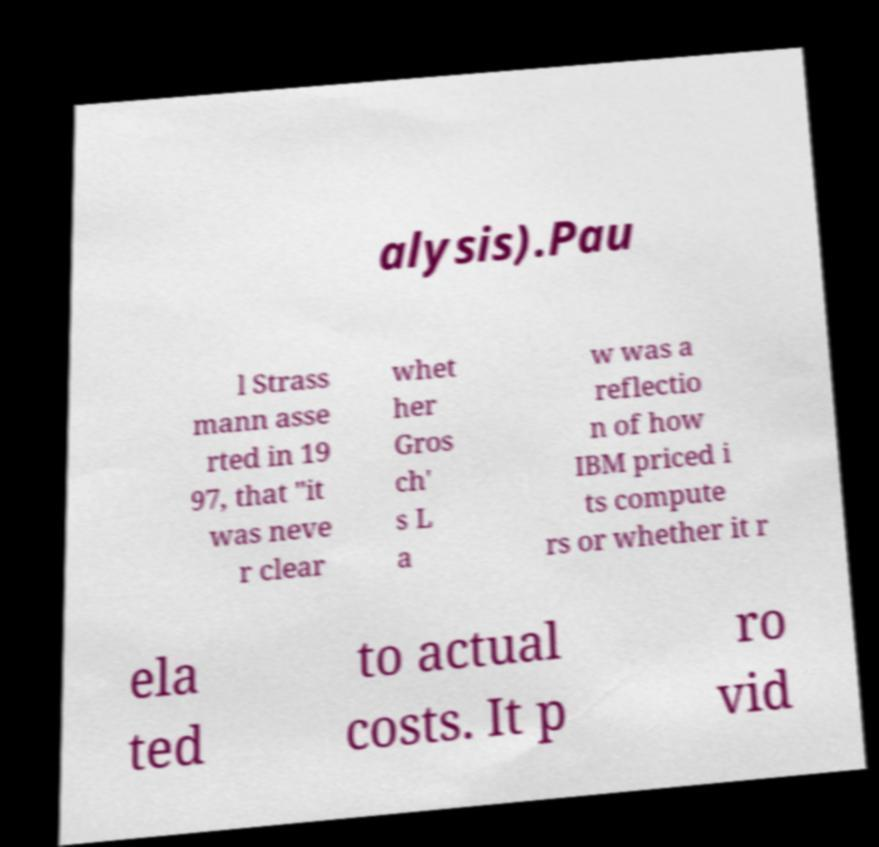For documentation purposes, I need the text within this image transcribed. Could you provide that? alysis).Pau l Strass mann asse rted in 19 97, that "it was neve r clear whet her Gros ch' s L a w was a reflectio n of how IBM priced i ts compute rs or whether it r ela ted to actual costs. It p ro vid 